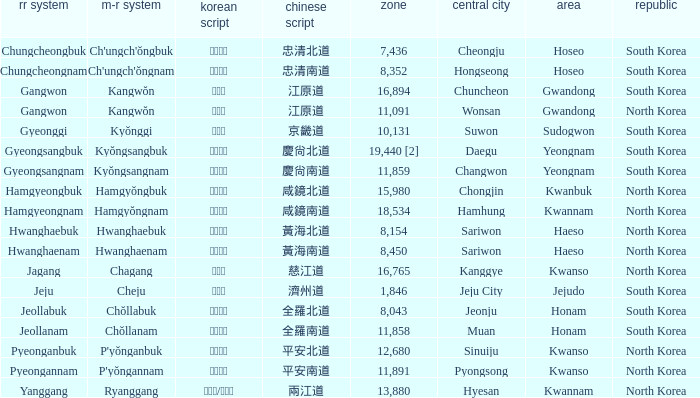Could you parse the entire table as a dict? {'header': ['rr system', 'm-r system', 'korean script', 'chinese script', 'zone', 'central city', 'area', 'republic'], 'rows': [['Chungcheongbuk', "Ch'ungch'ŏngbuk", '충청북도', '忠清北道', '7,436', 'Cheongju', 'Hoseo', 'South Korea'], ['Chungcheongnam', "Ch'ungch'ŏngnam", '충청남도', '忠清南道', '8,352', 'Hongseong', 'Hoseo', 'South Korea'], ['Gangwon', 'Kangwŏn', '강원도', '江原道', '16,894', 'Chuncheon', 'Gwandong', 'South Korea'], ['Gangwon', 'Kangwŏn', '강원도', '江原道', '11,091', 'Wonsan', 'Gwandong', 'North Korea'], ['Gyeonggi', 'Kyŏnggi', '경기도', '京畿道', '10,131', 'Suwon', 'Sudogwon', 'South Korea'], ['Gyeongsangbuk', 'Kyŏngsangbuk', '경상북도', '慶尙北道', '19,440 [2]', 'Daegu', 'Yeongnam', 'South Korea'], ['Gyeongsangnam', 'Kyŏngsangnam', '경상남도', '慶尙南道', '11,859', 'Changwon', 'Yeongnam', 'South Korea'], ['Hamgyeongbuk', 'Hamgyŏngbuk', '함경북도', '咸鏡北道', '15,980', 'Chongjin', 'Kwanbuk', 'North Korea'], ['Hamgyeongnam', 'Hamgyŏngnam', '함경남도', '咸鏡南道', '18,534', 'Hamhung', 'Kwannam', 'North Korea'], ['Hwanghaebuk', 'Hwanghaebuk', '황해북도', '黃海北道', '8,154', 'Sariwon', 'Haeso', 'North Korea'], ['Hwanghaenam', 'Hwanghaenam', '황해남도', '黃海南道', '8,450', 'Sariwon', 'Haeso', 'North Korea'], ['Jagang', 'Chagang', '자강도', '慈江道', '16,765', 'Kanggye', 'Kwanso', 'North Korea'], ['Jeju', 'Cheju', '제주도', '濟州道', '1,846', 'Jeju City', 'Jejudo', 'South Korea'], ['Jeollabuk', 'Chŏllabuk', '전라북도', '全羅北道', '8,043', 'Jeonju', 'Honam', 'South Korea'], ['Jeollanam', 'Chŏllanam', '전라남도', '全羅南道', '11,858', 'Muan', 'Honam', 'South Korea'], ['Pyeonganbuk', "P'yŏnganbuk", '평안북도', '平安北道', '12,680', 'Sinuiju', 'Kwanso', 'North Korea'], ['Pyeongannam', "P'yŏngannam", '평안남도', '平安南道', '11,891', 'Pyongsong', 'Kwanso', 'North Korea'], ['Yanggang', 'Ryanggang', '량강도/양강도', '兩江道', '13,880', 'Hyesan', 'Kwannam', 'North Korea']]} What is the M-R Romaja for the province having a capital of Cheongju? Ch'ungch'ŏngbuk. 